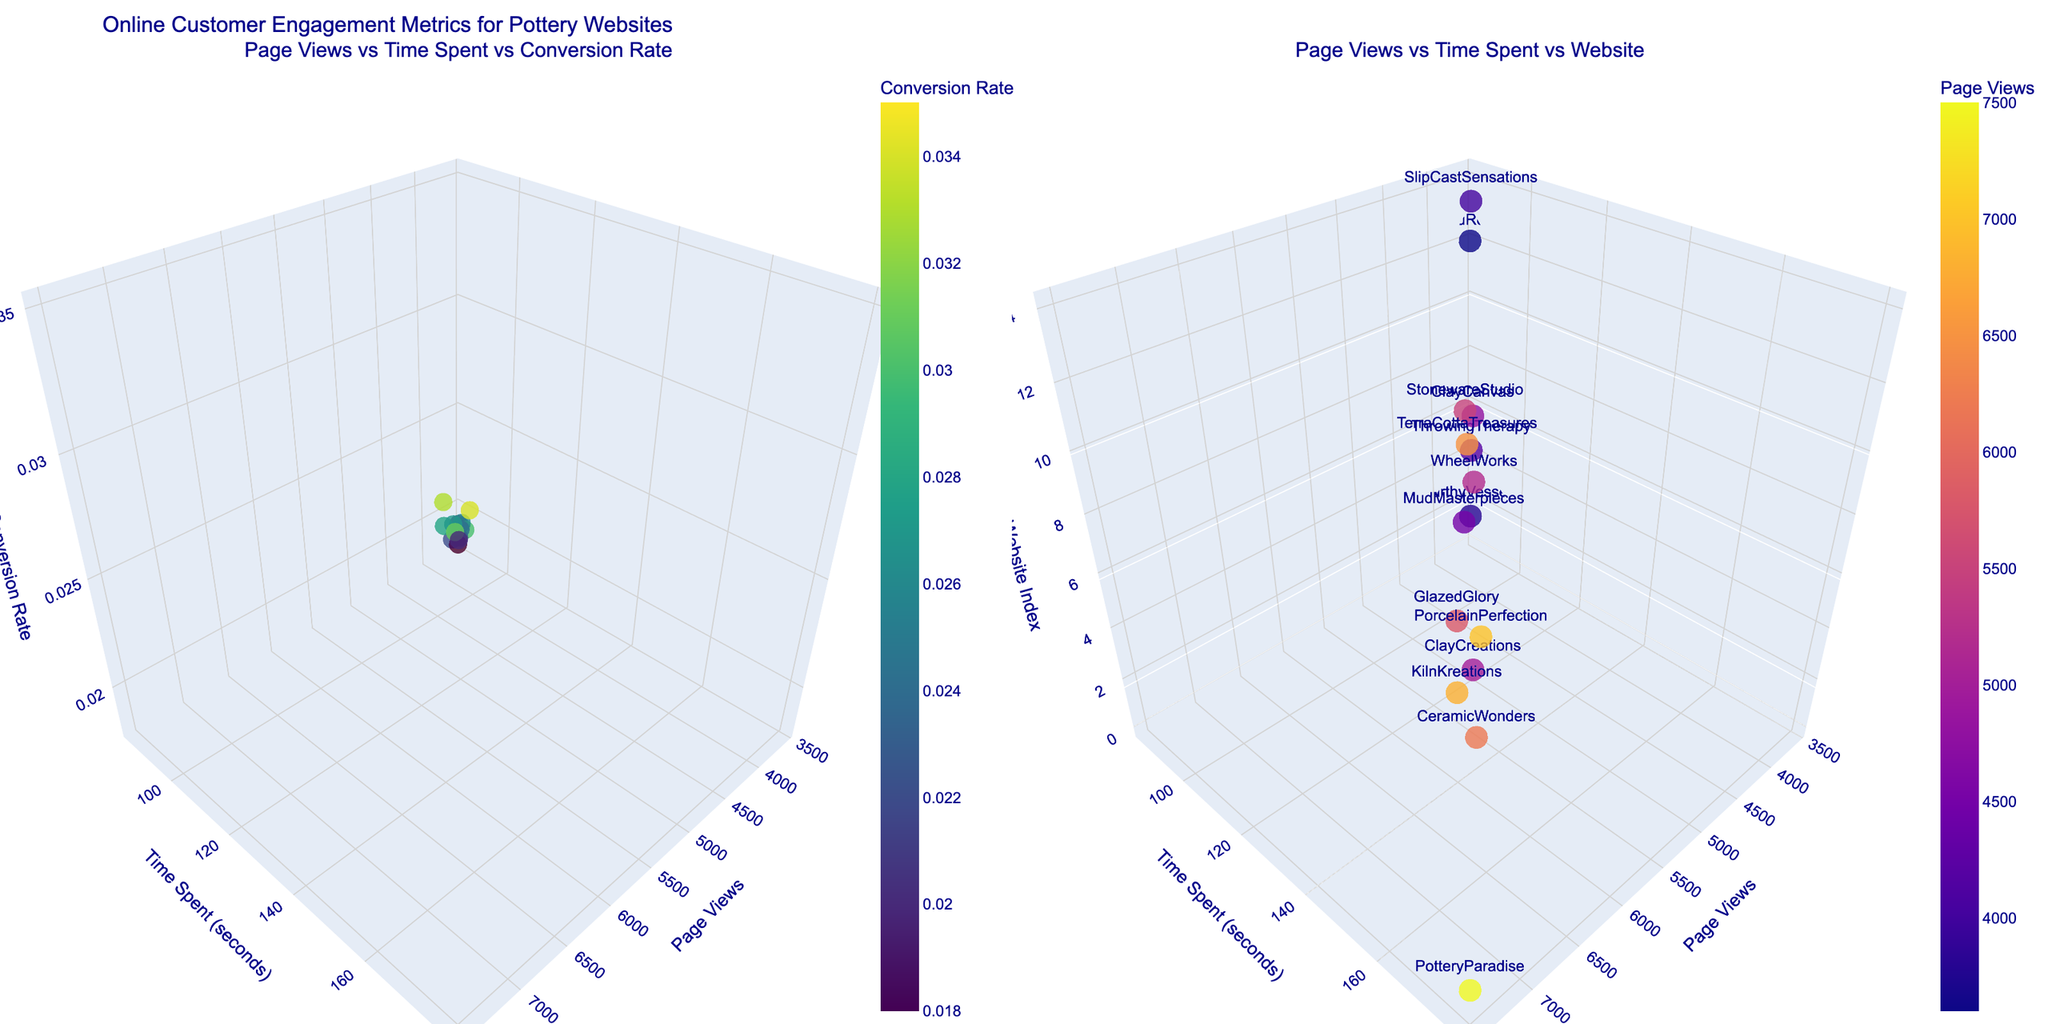What is the title of the figure? The title is located at the top of the plot and provides an overview of what the figure represents.
Answer: Online Customer Engagement Metrics for Pottery Websites How many data points are represented in the first 3D scatter plot? By counting the number of markers (points) in the graph, we can deduce the number of data points.
Answer: 15 Which website has the highest conversion rate and what is that rate? Identify the point with the highest position on the conversion rate (z-axis) in the first 3D scatter plot, then check the hover information to find the website name and its rate.
Answer: PotteryParadise at 0.035 Which axis represents the amount of time customers spend on the website in the second 3D scatter plot? By looking at the axis labels in the second 3D plot, we can determine which axis corresponds to time spent by customers.
Answer: Y-axis Do websites with higher page views always have higher conversion rates in the first 3D plot? By visually examining the correlation between the x-axis (page views) and the z-axis (conversion rate) in the first plot, we can identify if higher page views consistently align with higher conversion rates.
Answer: No What is the range of time spent by users on the websites? By reading the minimum and maximum values on the y-axis of the plots, we can determine the range.
Answer: 85 to 180 seconds Name the websites that have a time spent value of 160 seconds in the second 3D scatter plot. By hovering over the markers along the y-axis value of 160 seconds in the second 3D plot, we can check the text labels for website names.
Answer: KilnKreations Which website has the lowest page views, and how many page views does it have? Identify the point with the lowest x-axis value in either 3D scatter plot and use the hover information to find the website name and page views.
Answer: RakuRealm with 3600 page views What is the average conversion rate across all websites? Sum the conversion rates of all websites and divide by the number of websites (15) to find the average.
Answer: (Sum of all conversion rates) / 15 = 0.027 Is there a visible trend between time spent on a website and its conversion rate in the first 3D scatter plot? By examining the relationship between the y-axis (time spent) and the z-axis (conversion rate), we can determine if there's an observable trend, such as increasing or decreasing conversion rates with time.
Answer: Slight positive trend 